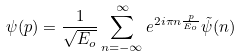<formula> <loc_0><loc_0><loc_500><loc_500>\psi ( p ) = \frac { 1 } { \sqrt { E _ { o } } } \sum _ { n = - \infty } ^ { \infty } e ^ { 2 i \pi n \frac { p } { E _ { o } } } \tilde { \psi } ( n )</formula> 